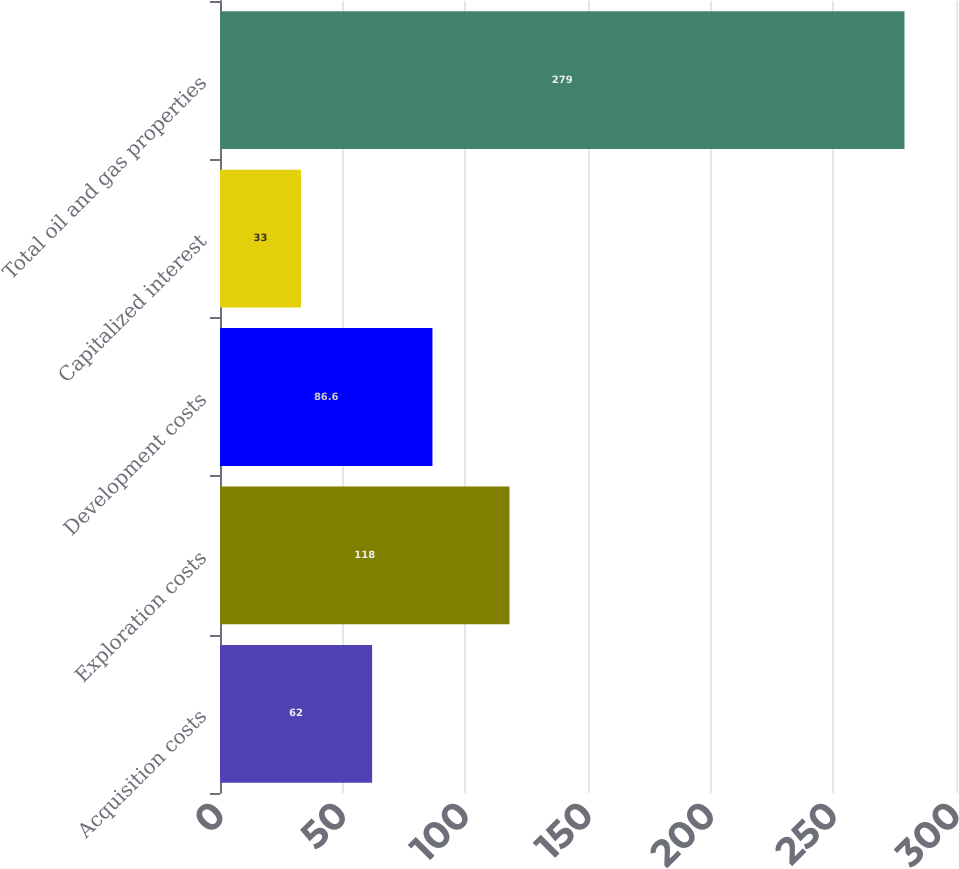<chart> <loc_0><loc_0><loc_500><loc_500><bar_chart><fcel>Acquisition costs<fcel>Exploration costs<fcel>Development costs<fcel>Capitalized interest<fcel>Total oil and gas properties<nl><fcel>62<fcel>118<fcel>86.6<fcel>33<fcel>279<nl></chart> 